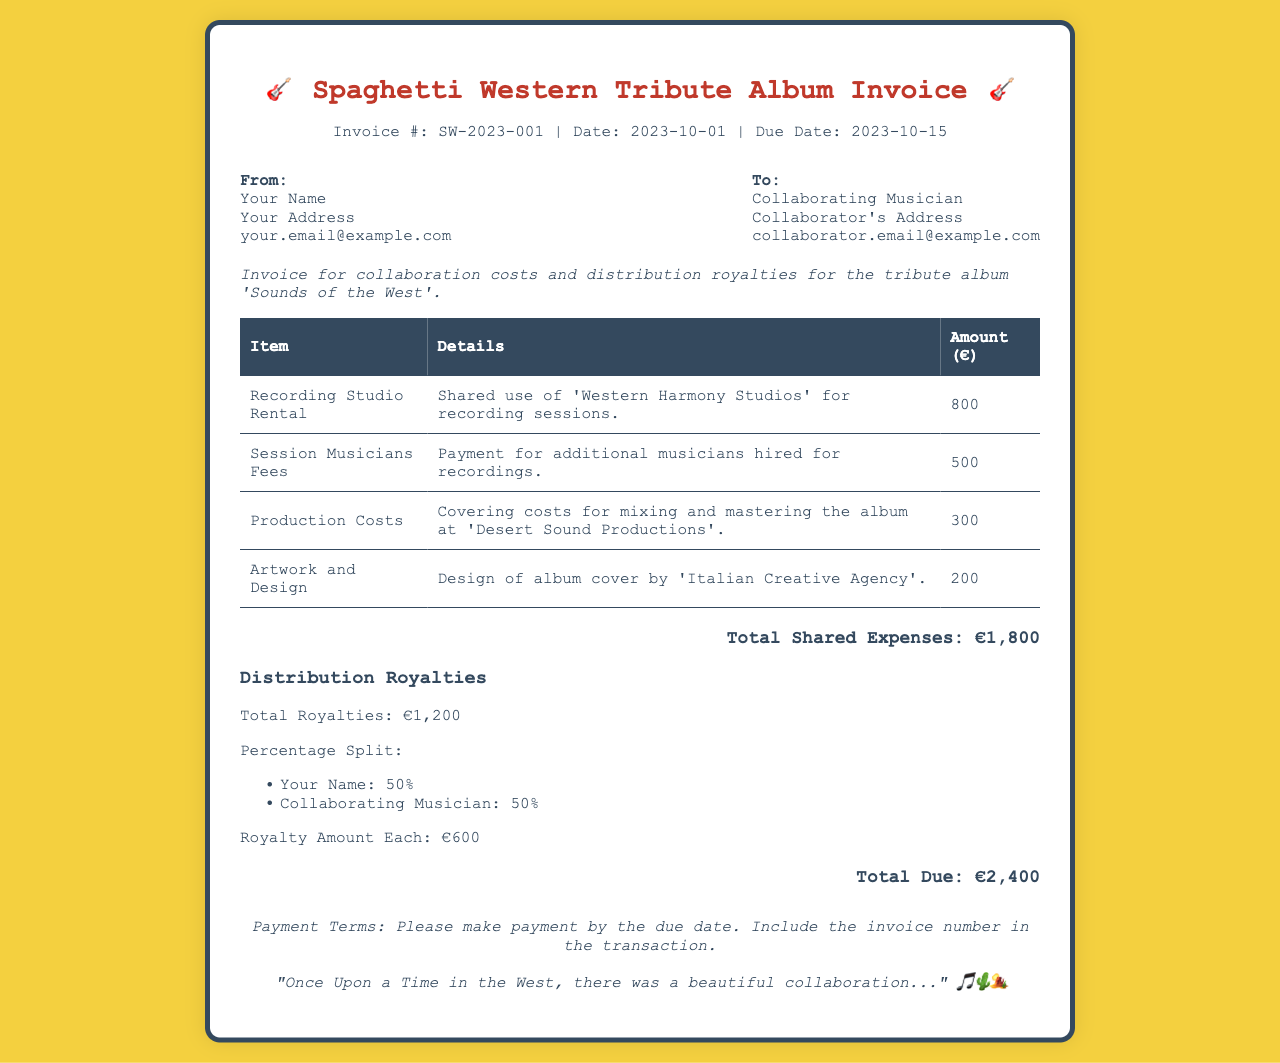What is the invoice number? The invoice number is provided in the document as a unique identifier for this transaction.
Answer: SW-2023-001 What is the total shared expenses? The total shared expenses are calculated by adding all the individual expenses listed in the invoice.
Answer: €1,800 Who is the collaborating musician? The document specifies the name of the collaborating musician who is receiving the invoice.
Answer: Collaborating Musician What is the total due amount? The total due amount is the sum of the total shared expenses and the total royalties.
Answer: €2,400 What is the date the invoice was issued? The date of the invoice indicates when the invoice was created and is noted in the document.
Answer: 2023-10-01 What are the percentages for the royalty split? The invoice states the distribution of royalties, showing how much each collaborator receives.
Answer: 50% What is the purpose of this invoice? The purpose outlines the reason for creating the invoice, which includes collaboration costs and royalties.
Answer: Tribute album 'Sounds of the West' What is the due date for payment? The due date indicates by when the payment should be made to avoid penalties.
Answer: 2023-10-15 What is included in the production costs? The production costs indicate what expenses cover the mixing and mastering of the album.
Answer: Mixing and mastering the album at 'Desert Sound Productions' 